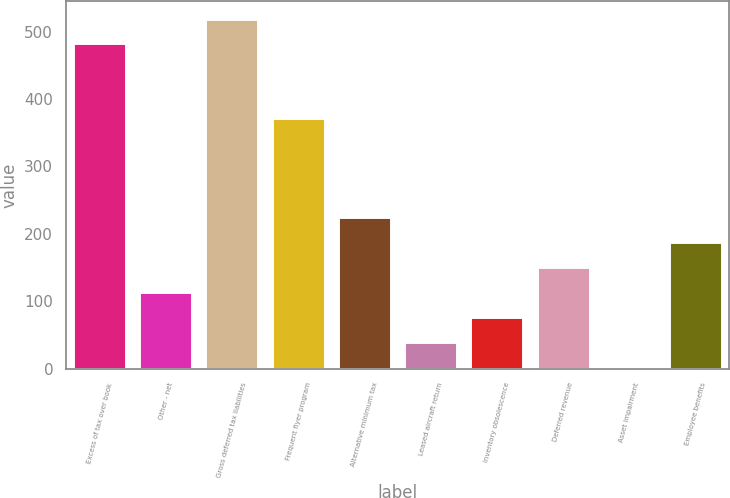Convert chart. <chart><loc_0><loc_0><loc_500><loc_500><bar_chart><fcel>Excess of tax over book<fcel>Other - net<fcel>Gross deferred tax liabilities<fcel>Frequent flyer program<fcel>Alternative minimum tax<fcel>Leased aircraft return<fcel>Inventory obsolescence<fcel>Deferred revenue<fcel>Asset impairment<fcel>Employee benefits<nl><fcel>482.38<fcel>113.78<fcel>519.24<fcel>371.8<fcel>224.36<fcel>40.06<fcel>76.92<fcel>150.64<fcel>3.2<fcel>187.5<nl></chart> 